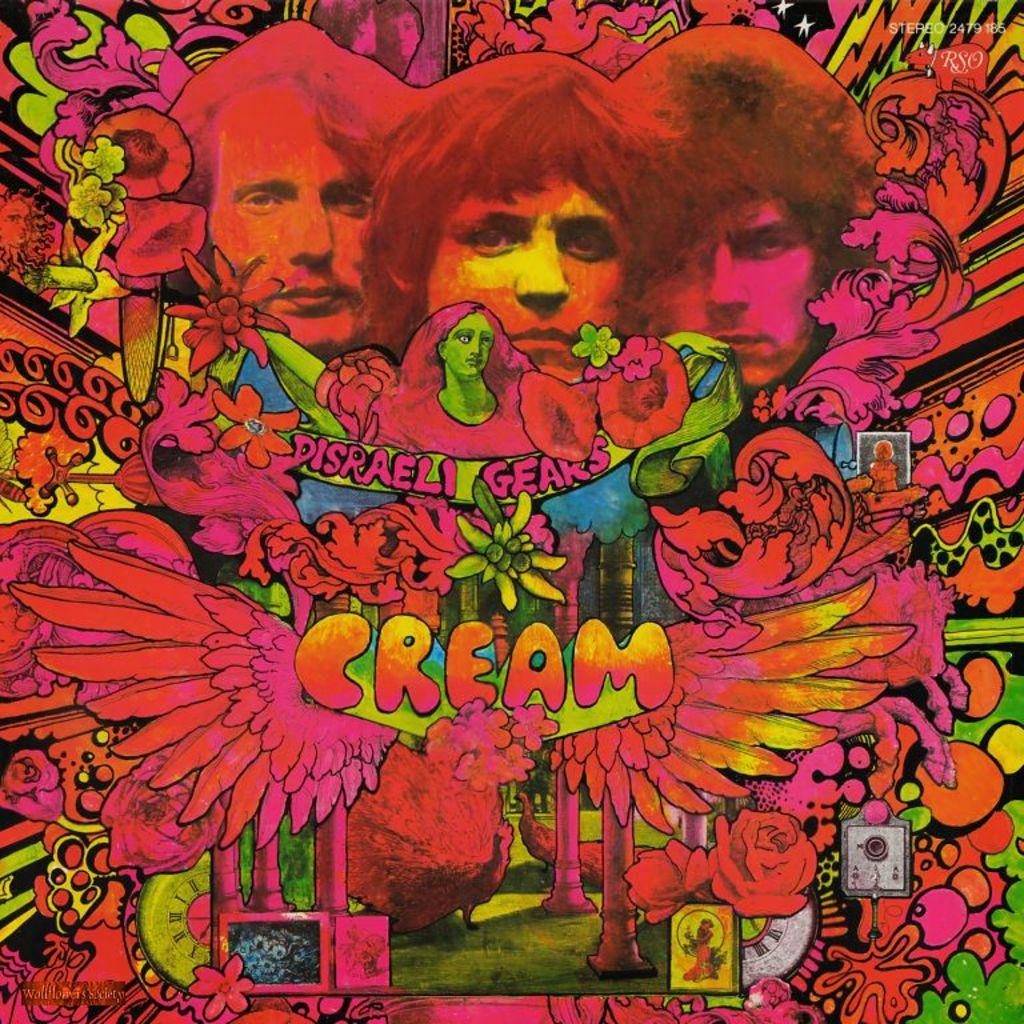What word has wings around it?
Make the answer very short. Cream. 